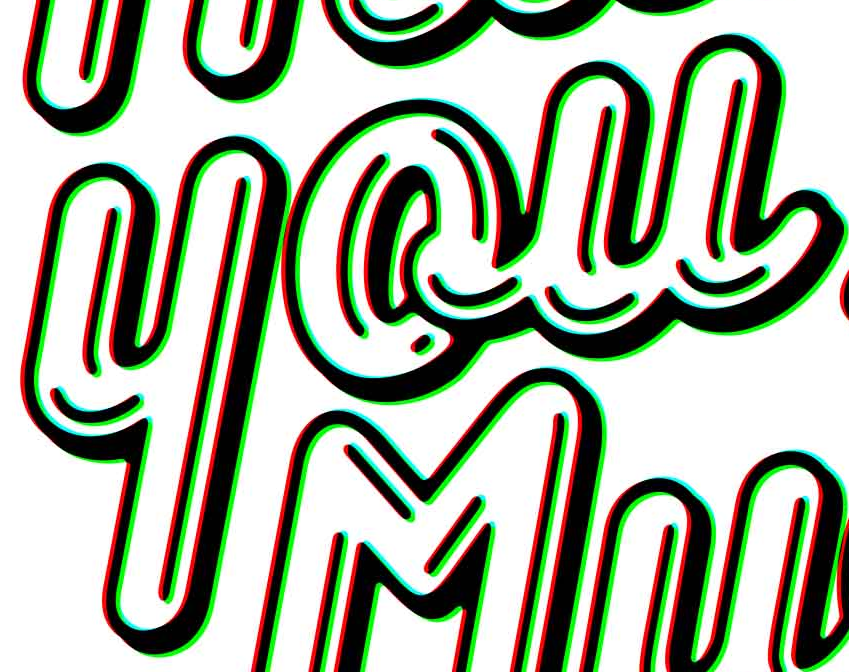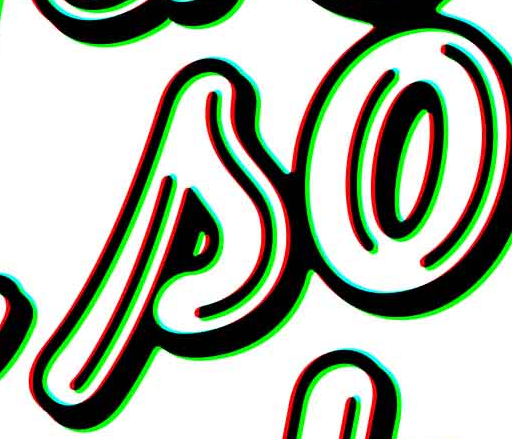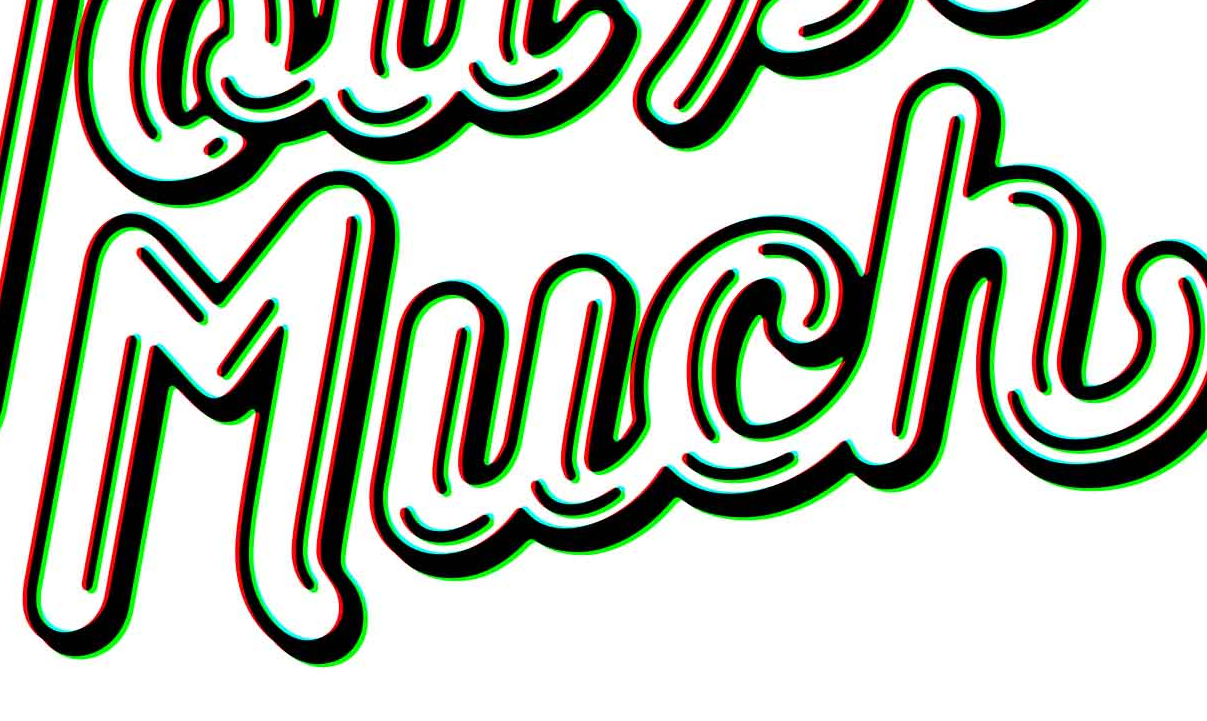What words can you see in these images in sequence, separated by a semicolon? you; so; Much 